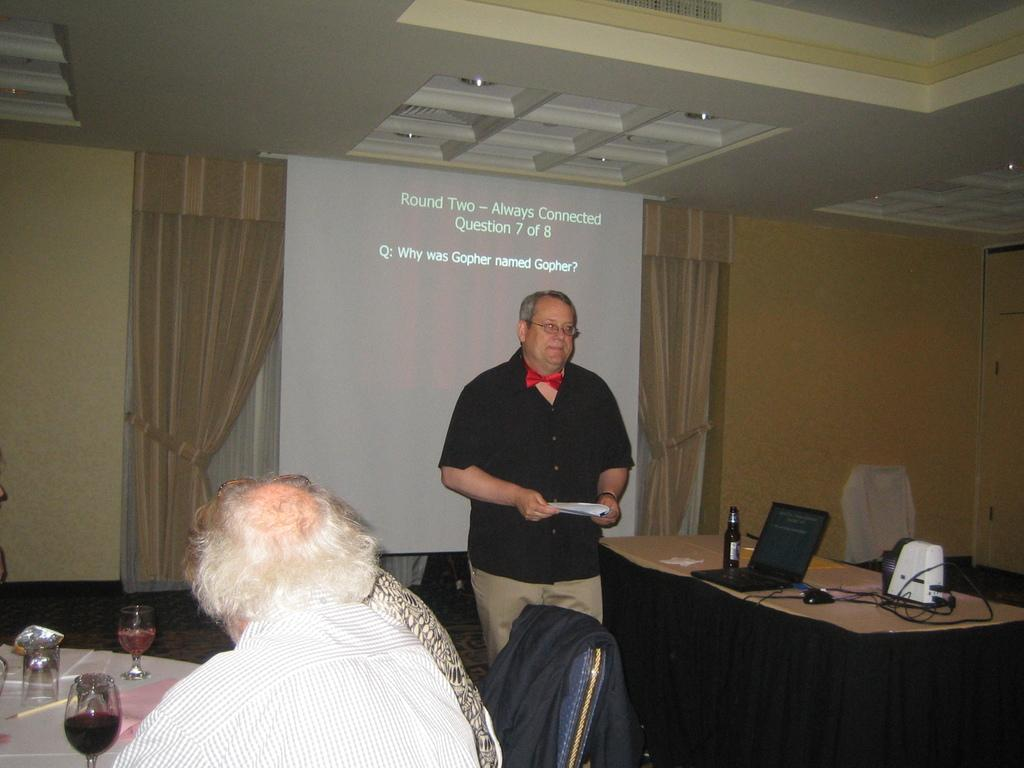Who is the main subject in the image? There is a guy in the image. What is the guy doing in the image? The guy is in front of a screen and explaining something. Can you describe the setting where the guy is located? There are people sitting at a table in the image. What objects are on the table? There are glasses on the table. What type of dress is the guy wearing in the image? The image does not show the guy wearing a dress; he is wearing regular clothing. 